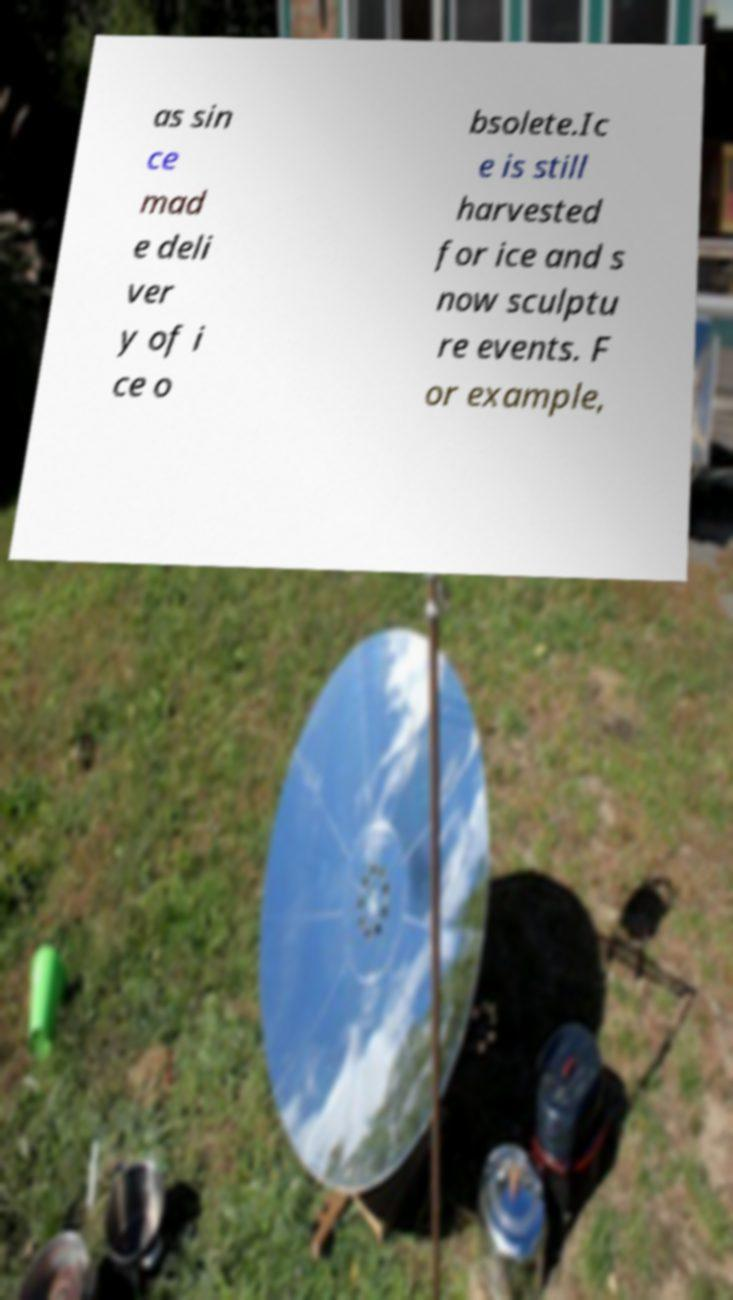Could you assist in decoding the text presented in this image and type it out clearly? as sin ce mad e deli ver y of i ce o bsolete.Ic e is still harvested for ice and s now sculptu re events. F or example, 